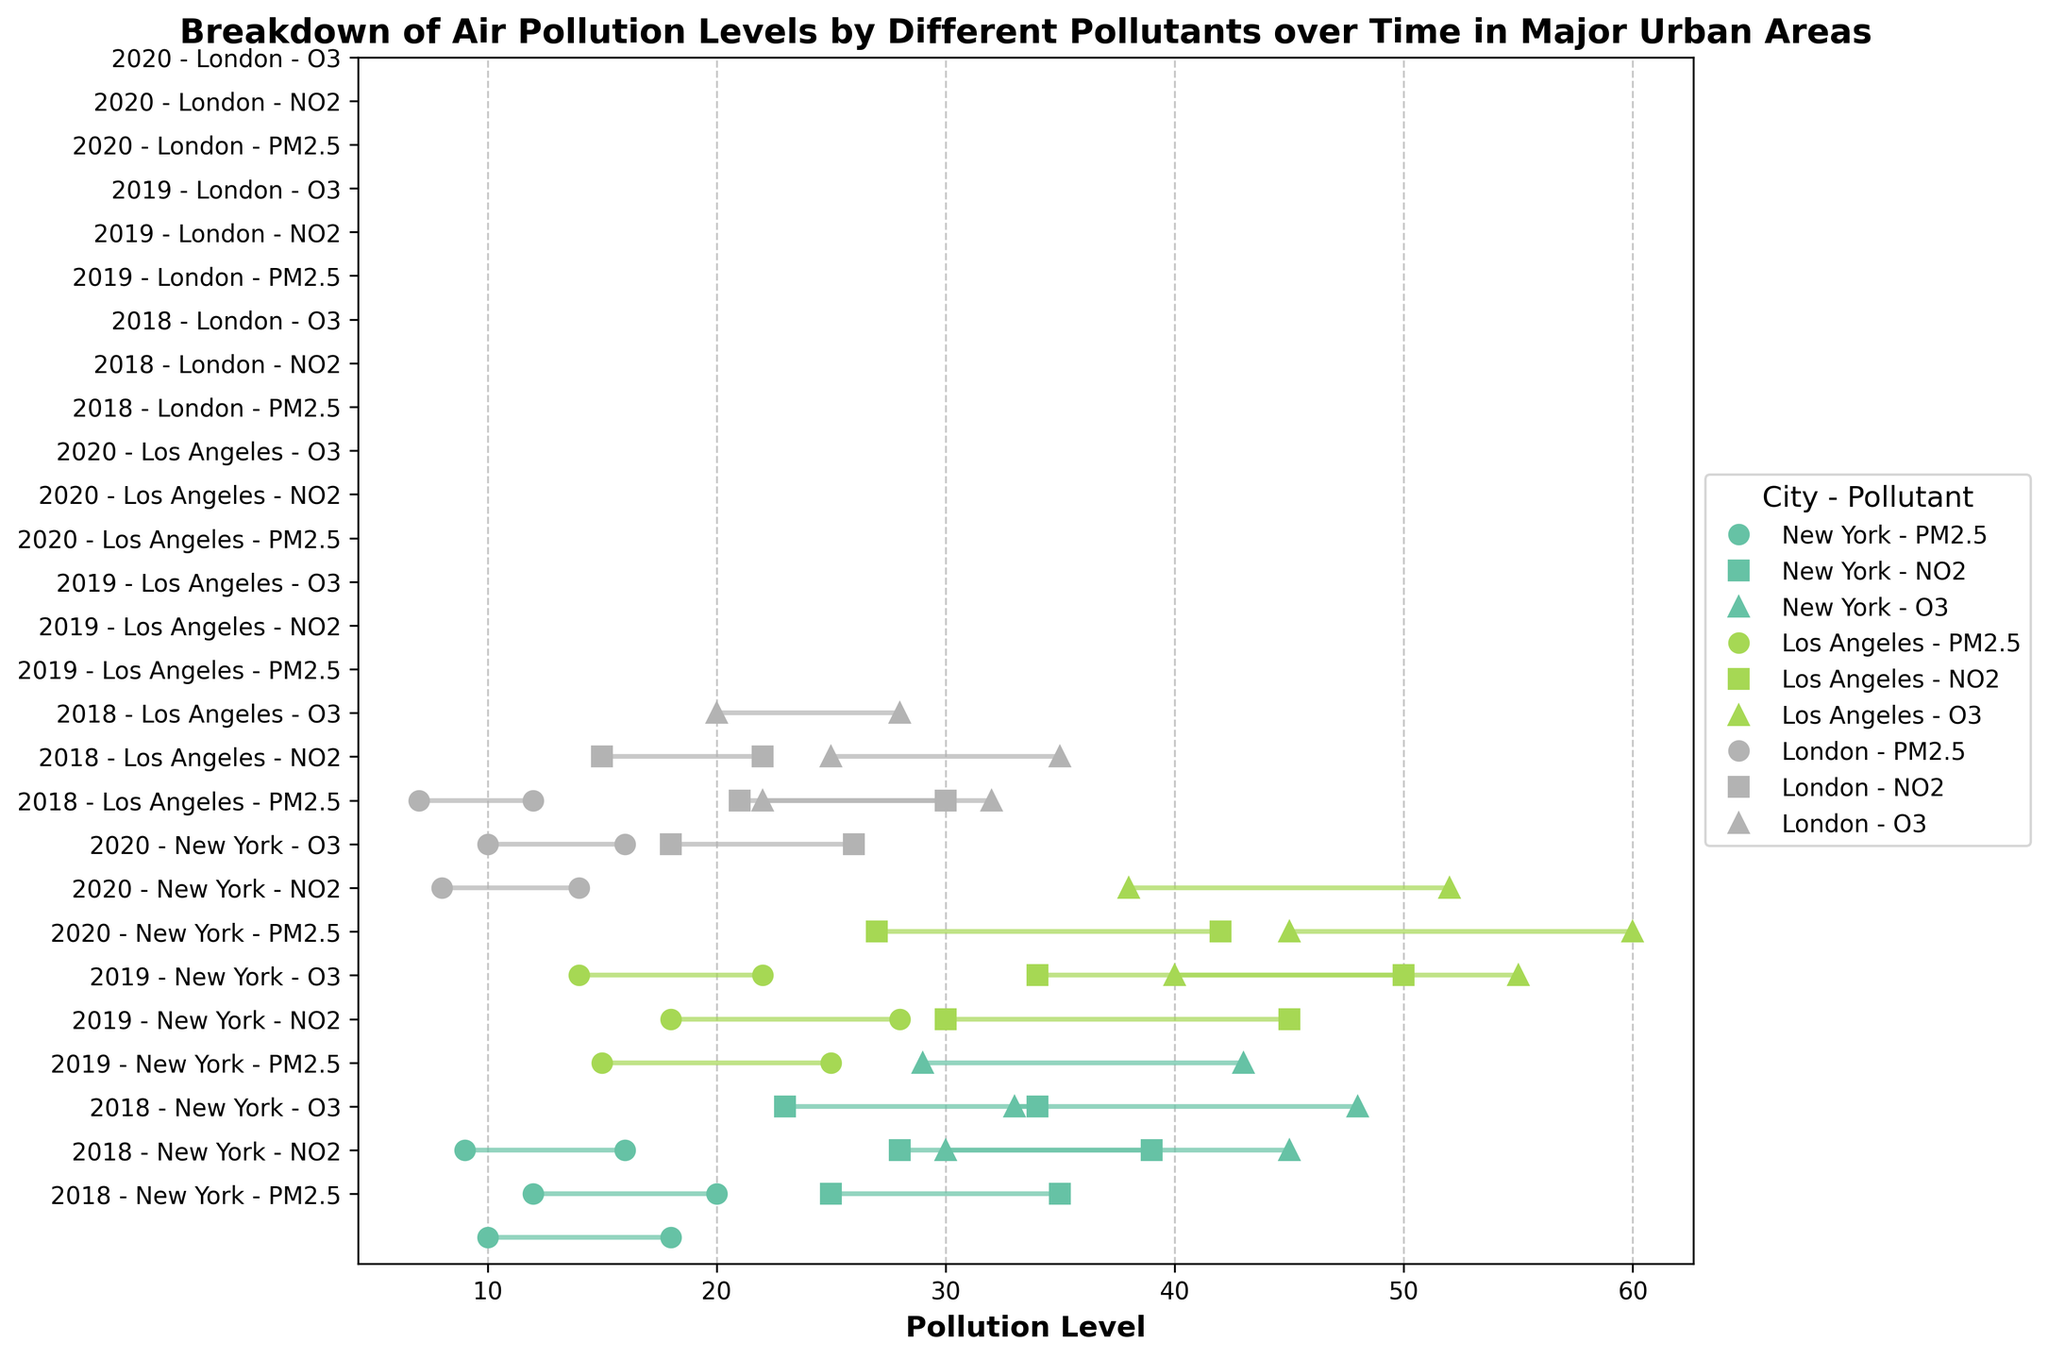How many pollutants are tracked for each city? The figure shows three different markers corresponding to three types of pollutants (PM2.5, NO2, O3) for each city in different colors.
Answer: 3 Which pollutant had the highest maximum level in Los Angeles in 2019? In Los Angeles, 2019, the maximum levels of pollutants are marked with different markers. PM2.5 is up to 28, NO2 is up to 50, and O3 is up to 60. The highest maximum level is for O3.
Answer: O3 What is the difference between the maximum level of NO2 and O3 in New York for 2019? In New York for 2019, max NO2 is 39 and max O3 is 48. The difference is 48 - 39 = 9.
Answer: 9 Which city had the lowest minimum level of PM2.5 in 2020? The minimum levels are shown at the leftmost points of each ranged dot. In 2020, New York has the lowest with 9, Los Angeles with 14, and London with 7. Hence, London.
Answer: London For New York in 2019, what's the average of the maximum levels across the three pollutants? The max levels for NO2, PM2.5, and O3 are 39, 20, and 48 respectively. The average is (39 + 20 + 48) / 3 = 107 / 3 ≈ 35.67.
Answer: 35.67 Which year had the highest maximum level of PM2.5 in New York? For PM2.5 in New York, max levels are 18 (2018), 20 (2019), and 16 (2020). The highest is for 2019 with 20.
Answer: 2019 Between 2018 and 2020, did the maximum level of NO2 in London increase or decrease? The maximum levels of NO2 in London are: 2018 - 26, 2019 - 30, and 2020 - 22. Comparing 2018 (26) to 2020 (22), it decreased.
Answer: Decrease Which pollutant in Los Angeles had the smallest range in 2020? The ranges are the difference between max and min. For Los Angeles 2020: PM2.5 (22-14=8), NO2 (42-27=15), O3 (52-38=14). The smallest range is for PM2.5.
Answer: PM2.5 